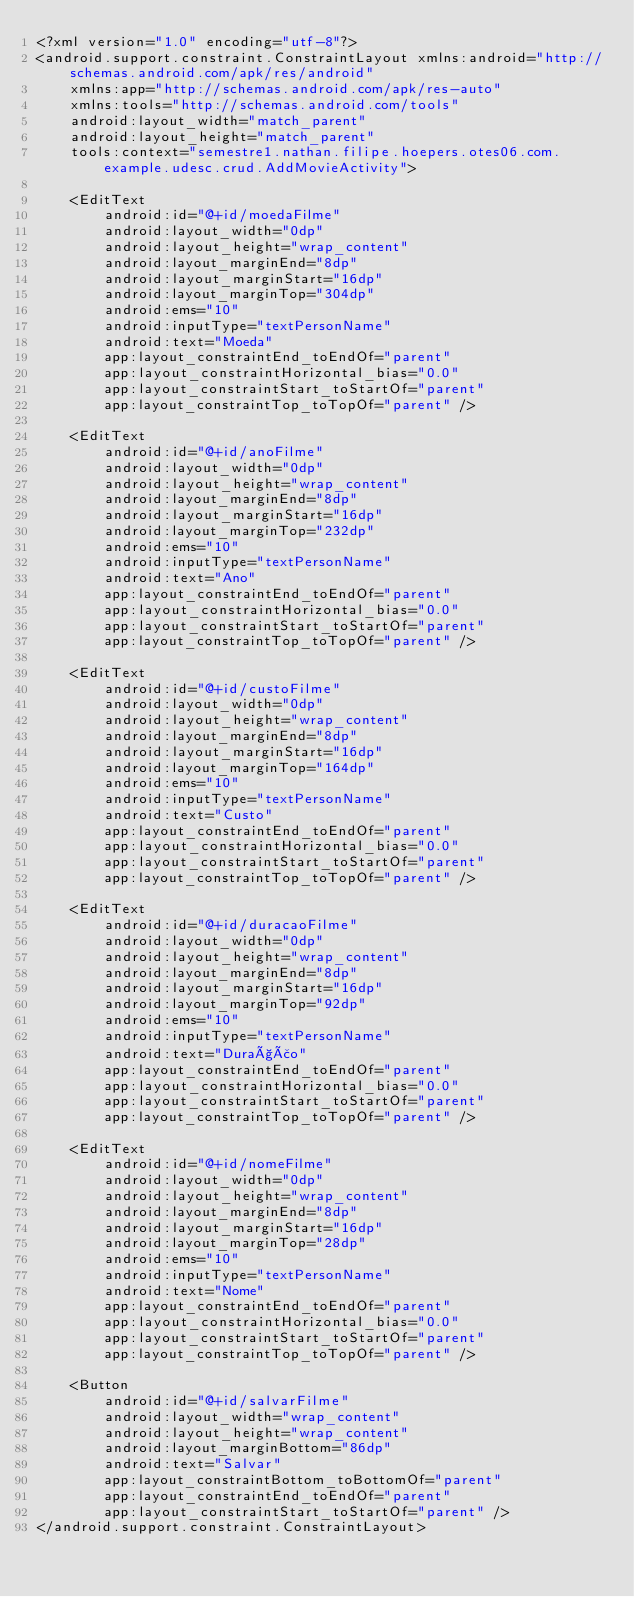Convert code to text. <code><loc_0><loc_0><loc_500><loc_500><_XML_><?xml version="1.0" encoding="utf-8"?>
<android.support.constraint.ConstraintLayout xmlns:android="http://schemas.android.com/apk/res/android"
    xmlns:app="http://schemas.android.com/apk/res-auto"
    xmlns:tools="http://schemas.android.com/tools"
    android:layout_width="match_parent"
    android:layout_height="match_parent"
    tools:context="semestre1.nathan.filipe.hoepers.otes06.com.example.udesc.crud.AddMovieActivity">

    <EditText
        android:id="@+id/moedaFilme"
        android:layout_width="0dp"
        android:layout_height="wrap_content"
        android:layout_marginEnd="8dp"
        android:layout_marginStart="16dp"
        android:layout_marginTop="304dp"
        android:ems="10"
        android:inputType="textPersonName"
        android:text="Moeda"
        app:layout_constraintEnd_toEndOf="parent"
        app:layout_constraintHorizontal_bias="0.0"
        app:layout_constraintStart_toStartOf="parent"
        app:layout_constraintTop_toTopOf="parent" />

    <EditText
        android:id="@+id/anoFilme"
        android:layout_width="0dp"
        android:layout_height="wrap_content"
        android:layout_marginEnd="8dp"
        android:layout_marginStart="16dp"
        android:layout_marginTop="232dp"
        android:ems="10"
        android:inputType="textPersonName"
        android:text="Ano"
        app:layout_constraintEnd_toEndOf="parent"
        app:layout_constraintHorizontal_bias="0.0"
        app:layout_constraintStart_toStartOf="parent"
        app:layout_constraintTop_toTopOf="parent" />

    <EditText
        android:id="@+id/custoFilme"
        android:layout_width="0dp"
        android:layout_height="wrap_content"
        android:layout_marginEnd="8dp"
        android:layout_marginStart="16dp"
        android:layout_marginTop="164dp"
        android:ems="10"
        android:inputType="textPersonName"
        android:text="Custo"
        app:layout_constraintEnd_toEndOf="parent"
        app:layout_constraintHorizontal_bias="0.0"
        app:layout_constraintStart_toStartOf="parent"
        app:layout_constraintTop_toTopOf="parent" />

    <EditText
        android:id="@+id/duracaoFilme"
        android:layout_width="0dp"
        android:layout_height="wrap_content"
        android:layout_marginEnd="8dp"
        android:layout_marginStart="16dp"
        android:layout_marginTop="92dp"
        android:ems="10"
        android:inputType="textPersonName"
        android:text="Duração"
        app:layout_constraintEnd_toEndOf="parent"
        app:layout_constraintHorizontal_bias="0.0"
        app:layout_constraintStart_toStartOf="parent"
        app:layout_constraintTop_toTopOf="parent" />

    <EditText
        android:id="@+id/nomeFilme"
        android:layout_width="0dp"
        android:layout_height="wrap_content"
        android:layout_marginEnd="8dp"
        android:layout_marginStart="16dp"
        android:layout_marginTop="28dp"
        android:ems="10"
        android:inputType="textPersonName"
        android:text="Nome"
        app:layout_constraintEnd_toEndOf="parent"
        app:layout_constraintHorizontal_bias="0.0"
        app:layout_constraintStart_toStartOf="parent"
        app:layout_constraintTop_toTopOf="parent" />

    <Button
        android:id="@+id/salvarFilme"
        android:layout_width="wrap_content"
        android:layout_height="wrap_content"
        android:layout_marginBottom="86dp"
        android:text="Salvar"
        app:layout_constraintBottom_toBottomOf="parent"
        app:layout_constraintEnd_toEndOf="parent"
        app:layout_constraintStart_toStartOf="parent" />
</android.support.constraint.ConstraintLayout>
</code> 